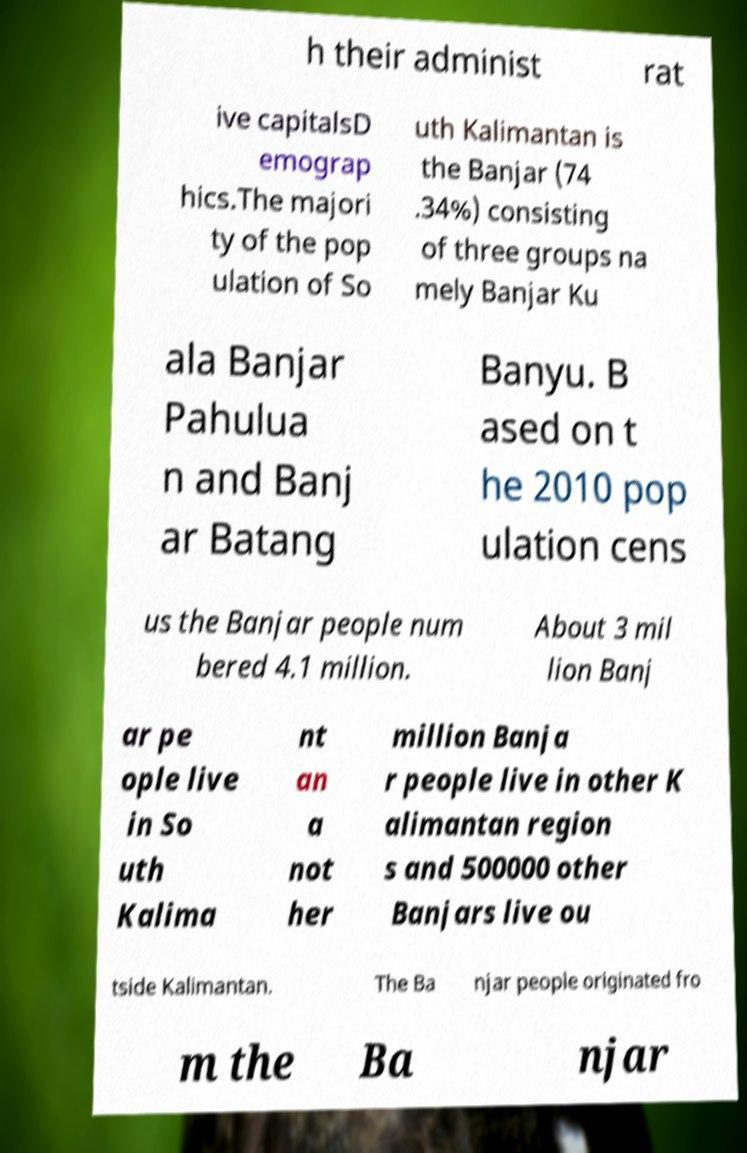What messages or text are displayed in this image? I need them in a readable, typed format. h their administ rat ive capitalsD emograp hics.The majori ty of the pop ulation of So uth Kalimantan is the Banjar (74 .34%) consisting of three groups na mely Banjar Ku ala Banjar Pahulua n and Banj ar Batang Banyu. B ased on t he 2010 pop ulation cens us the Banjar people num bered 4.1 million. About 3 mil lion Banj ar pe ople live in So uth Kalima nt an a not her million Banja r people live in other K alimantan region s and 500000 other Banjars live ou tside Kalimantan. The Ba njar people originated fro m the Ba njar 